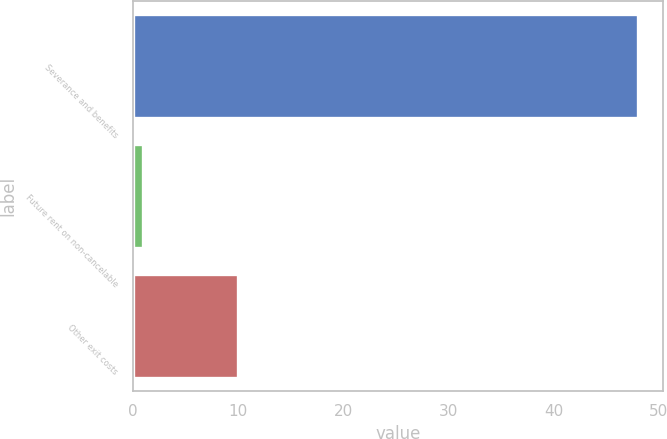Convert chart. <chart><loc_0><loc_0><loc_500><loc_500><bar_chart><fcel>Severance and benefits<fcel>Future rent on non-cancelable<fcel>Other exit costs<nl><fcel>48<fcel>1<fcel>10<nl></chart> 